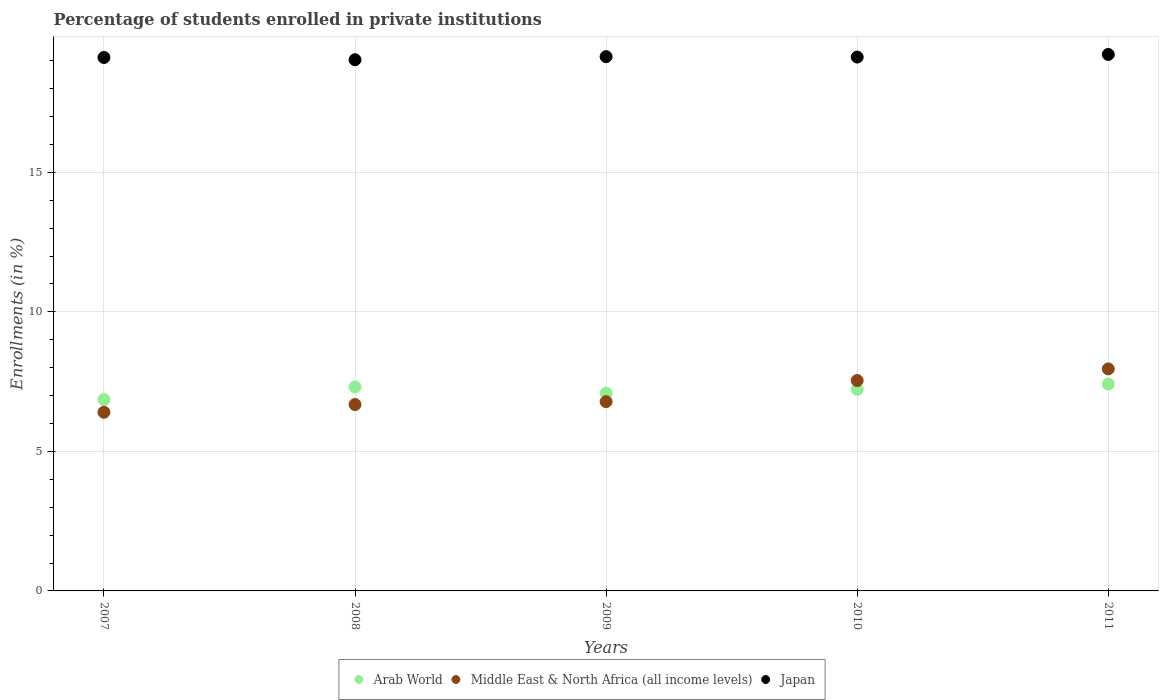How many different coloured dotlines are there?
Your response must be concise. 3. Is the number of dotlines equal to the number of legend labels?
Offer a terse response. Yes. What is the percentage of trained teachers in Arab World in 2011?
Provide a short and direct response. 7.41. Across all years, what is the maximum percentage of trained teachers in Middle East & North Africa (all income levels)?
Provide a succinct answer. 7.96. Across all years, what is the minimum percentage of trained teachers in Japan?
Ensure brevity in your answer.  19.04. What is the total percentage of trained teachers in Japan in the graph?
Give a very brief answer. 95.66. What is the difference between the percentage of trained teachers in Arab World in 2010 and that in 2011?
Your answer should be very brief. -0.19. What is the difference between the percentage of trained teachers in Arab World in 2011 and the percentage of trained teachers in Japan in 2007?
Give a very brief answer. -11.7. What is the average percentage of trained teachers in Japan per year?
Provide a succinct answer. 19.13. In the year 2008, what is the difference between the percentage of trained teachers in Japan and percentage of trained teachers in Middle East & North Africa (all income levels)?
Offer a terse response. 12.36. In how many years, is the percentage of trained teachers in Arab World greater than 18 %?
Your answer should be compact. 0. What is the ratio of the percentage of trained teachers in Japan in 2009 to that in 2010?
Offer a very short reply. 1. Is the percentage of trained teachers in Arab World in 2007 less than that in 2011?
Offer a terse response. Yes. Is the difference between the percentage of trained teachers in Japan in 2009 and 2011 greater than the difference between the percentage of trained teachers in Middle East & North Africa (all income levels) in 2009 and 2011?
Your answer should be compact. Yes. What is the difference between the highest and the second highest percentage of trained teachers in Japan?
Keep it short and to the point. 0.08. What is the difference between the highest and the lowest percentage of trained teachers in Japan?
Your answer should be compact. 0.19. Is the sum of the percentage of trained teachers in Arab World in 2010 and 2011 greater than the maximum percentage of trained teachers in Middle East & North Africa (all income levels) across all years?
Your answer should be very brief. Yes. Is the percentage of trained teachers in Japan strictly greater than the percentage of trained teachers in Middle East & North Africa (all income levels) over the years?
Offer a terse response. Yes. Is the percentage of trained teachers in Arab World strictly less than the percentage of trained teachers in Middle East & North Africa (all income levels) over the years?
Keep it short and to the point. No. How many dotlines are there?
Keep it short and to the point. 3. Are the values on the major ticks of Y-axis written in scientific E-notation?
Offer a terse response. No. Does the graph contain grids?
Offer a very short reply. Yes. How many legend labels are there?
Offer a very short reply. 3. How are the legend labels stacked?
Provide a succinct answer. Horizontal. What is the title of the graph?
Your answer should be compact. Percentage of students enrolled in private institutions. What is the label or title of the Y-axis?
Keep it short and to the point. Enrollments (in %). What is the Enrollments (in %) of Arab World in 2007?
Give a very brief answer. 6.86. What is the Enrollments (in %) of Middle East & North Africa (all income levels) in 2007?
Keep it short and to the point. 6.4. What is the Enrollments (in %) in Japan in 2007?
Your answer should be very brief. 19.12. What is the Enrollments (in %) in Arab World in 2008?
Make the answer very short. 7.31. What is the Enrollments (in %) in Middle East & North Africa (all income levels) in 2008?
Ensure brevity in your answer.  6.68. What is the Enrollments (in %) of Japan in 2008?
Make the answer very short. 19.04. What is the Enrollments (in %) of Arab World in 2009?
Make the answer very short. 7.09. What is the Enrollments (in %) in Middle East & North Africa (all income levels) in 2009?
Your response must be concise. 6.78. What is the Enrollments (in %) in Japan in 2009?
Offer a terse response. 19.15. What is the Enrollments (in %) in Arab World in 2010?
Your response must be concise. 7.23. What is the Enrollments (in %) in Middle East & North Africa (all income levels) in 2010?
Provide a succinct answer. 7.54. What is the Enrollments (in %) of Japan in 2010?
Your answer should be compact. 19.13. What is the Enrollments (in %) of Arab World in 2011?
Ensure brevity in your answer.  7.41. What is the Enrollments (in %) of Middle East & North Africa (all income levels) in 2011?
Offer a terse response. 7.96. What is the Enrollments (in %) in Japan in 2011?
Give a very brief answer. 19.22. Across all years, what is the maximum Enrollments (in %) in Arab World?
Make the answer very short. 7.41. Across all years, what is the maximum Enrollments (in %) of Middle East & North Africa (all income levels)?
Provide a short and direct response. 7.96. Across all years, what is the maximum Enrollments (in %) in Japan?
Provide a succinct answer. 19.22. Across all years, what is the minimum Enrollments (in %) of Arab World?
Ensure brevity in your answer.  6.86. Across all years, what is the minimum Enrollments (in %) in Middle East & North Africa (all income levels)?
Offer a terse response. 6.4. Across all years, what is the minimum Enrollments (in %) of Japan?
Ensure brevity in your answer.  19.04. What is the total Enrollments (in %) of Arab World in the graph?
Provide a succinct answer. 35.89. What is the total Enrollments (in %) of Middle East & North Africa (all income levels) in the graph?
Offer a very short reply. 35.36. What is the total Enrollments (in %) in Japan in the graph?
Your response must be concise. 95.66. What is the difference between the Enrollments (in %) in Arab World in 2007 and that in 2008?
Offer a very short reply. -0.45. What is the difference between the Enrollments (in %) of Middle East & North Africa (all income levels) in 2007 and that in 2008?
Make the answer very short. -0.28. What is the difference between the Enrollments (in %) of Japan in 2007 and that in 2008?
Provide a short and direct response. 0.08. What is the difference between the Enrollments (in %) of Arab World in 2007 and that in 2009?
Your answer should be very brief. -0.23. What is the difference between the Enrollments (in %) in Middle East & North Africa (all income levels) in 2007 and that in 2009?
Offer a very short reply. -0.38. What is the difference between the Enrollments (in %) in Japan in 2007 and that in 2009?
Your answer should be compact. -0.03. What is the difference between the Enrollments (in %) of Arab World in 2007 and that in 2010?
Your answer should be compact. -0.37. What is the difference between the Enrollments (in %) in Middle East & North Africa (all income levels) in 2007 and that in 2010?
Provide a succinct answer. -1.14. What is the difference between the Enrollments (in %) in Japan in 2007 and that in 2010?
Offer a very short reply. -0.02. What is the difference between the Enrollments (in %) in Arab World in 2007 and that in 2011?
Give a very brief answer. -0.55. What is the difference between the Enrollments (in %) in Middle East & North Africa (all income levels) in 2007 and that in 2011?
Your response must be concise. -1.55. What is the difference between the Enrollments (in %) of Japan in 2007 and that in 2011?
Your answer should be very brief. -0.11. What is the difference between the Enrollments (in %) in Arab World in 2008 and that in 2009?
Offer a terse response. 0.22. What is the difference between the Enrollments (in %) of Middle East & North Africa (all income levels) in 2008 and that in 2009?
Your response must be concise. -0.1. What is the difference between the Enrollments (in %) in Japan in 2008 and that in 2009?
Your response must be concise. -0.11. What is the difference between the Enrollments (in %) of Arab World in 2008 and that in 2010?
Give a very brief answer. 0.08. What is the difference between the Enrollments (in %) of Middle East & North Africa (all income levels) in 2008 and that in 2010?
Provide a short and direct response. -0.86. What is the difference between the Enrollments (in %) of Japan in 2008 and that in 2010?
Offer a terse response. -0.1. What is the difference between the Enrollments (in %) in Arab World in 2008 and that in 2011?
Offer a very short reply. -0.1. What is the difference between the Enrollments (in %) of Middle East & North Africa (all income levels) in 2008 and that in 2011?
Ensure brevity in your answer.  -1.28. What is the difference between the Enrollments (in %) in Japan in 2008 and that in 2011?
Provide a succinct answer. -0.19. What is the difference between the Enrollments (in %) of Arab World in 2009 and that in 2010?
Your response must be concise. -0.14. What is the difference between the Enrollments (in %) in Middle East & North Africa (all income levels) in 2009 and that in 2010?
Make the answer very short. -0.76. What is the difference between the Enrollments (in %) of Japan in 2009 and that in 2010?
Offer a very short reply. 0.01. What is the difference between the Enrollments (in %) in Arab World in 2009 and that in 2011?
Your answer should be compact. -0.33. What is the difference between the Enrollments (in %) of Middle East & North Africa (all income levels) in 2009 and that in 2011?
Ensure brevity in your answer.  -1.17. What is the difference between the Enrollments (in %) in Japan in 2009 and that in 2011?
Offer a terse response. -0.08. What is the difference between the Enrollments (in %) of Arab World in 2010 and that in 2011?
Provide a short and direct response. -0.19. What is the difference between the Enrollments (in %) of Middle East & North Africa (all income levels) in 2010 and that in 2011?
Offer a very short reply. -0.42. What is the difference between the Enrollments (in %) in Japan in 2010 and that in 2011?
Offer a terse response. -0.09. What is the difference between the Enrollments (in %) of Arab World in 2007 and the Enrollments (in %) of Middle East & North Africa (all income levels) in 2008?
Offer a very short reply. 0.18. What is the difference between the Enrollments (in %) of Arab World in 2007 and the Enrollments (in %) of Japan in 2008?
Provide a short and direct response. -12.18. What is the difference between the Enrollments (in %) of Middle East & North Africa (all income levels) in 2007 and the Enrollments (in %) of Japan in 2008?
Your response must be concise. -12.63. What is the difference between the Enrollments (in %) in Arab World in 2007 and the Enrollments (in %) in Middle East & North Africa (all income levels) in 2009?
Your answer should be very brief. 0.08. What is the difference between the Enrollments (in %) of Arab World in 2007 and the Enrollments (in %) of Japan in 2009?
Make the answer very short. -12.29. What is the difference between the Enrollments (in %) in Middle East & North Africa (all income levels) in 2007 and the Enrollments (in %) in Japan in 2009?
Provide a succinct answer. -12.74. What is the difference between the Enrollments (in %) in Arab World in 2007 and the Enrollments (in %) in Middle East & North Africa (all income levels) in 2010?
Give a very brief answer. -0.68. What is the difference between the Enrollments (in %) of Arab World in 2007 and the Enrollments (in %) of Japan in 2010?
Give a very brief answer. -12.27. What is the difference between the Enrollments (in %) of Middle East & North Africa (all income levels) in 2007 and the Enrollments (in %) of Japan in 2010?
Your response must be concise. -12.73. What is the difference between the Enrollments (in %) in Arab World in 2007 and the Enrollments (in %) in Middle East & North Africa (all income levels) in 2011?
Your answer should be compact. -1.1. What is the difference between the Enrollments (in %) of Arab World in 2007 and the Enrollments (in %) of Japan in 2011?
Offer a very short reply. -12.37. What is the difference between the Enrollments (in %) in Middle East & North Africa (all income levels) in 2007 and the Enrollments (in %) in Japan in 2011?
Your response must be concise. -12.82. What is the difference between the Enrollments (in %) of Arab World in 2008 and the Enrollments (in %) of Middle East & North Africa (all income levels) in 2009?
Keep it short and to the point. 0.53. What is the difference between the Enrollments (in %) in Arab World in 2008 and the Enrollments (in %) in Japan in 2009?
Keep it short and to the point. -11.84. What is the difference between the Enrollments (in %) of Middle East & North Africa (all income levels) in 2008 and the Enrollments (in %) of Japan in 2009?
Your response must be concise. -12.47. What is the difference between the Enrollments (in %) in Arab World in 2008 and the Enrollments (in %) in Middle East & North Africa (all income levels) in 2010?
Offer a terse response. -0.23. What is the difference between the Enrollments (in %) in Arab World in 2008 and the Enrollments (in %) in Japan in 2010?
Your answer should be very brief. -11.82. What is the difference between the Enrollments (in %) of Middle East & North Africa (all income levels) in 2008 and the Enrollments (in %) of Japan in 2010?
Make the answer very short. -12.45. What is the difference between the Enrollments (in %) in Arab World in 2008 and the Enrollments (in %) in Middle East & North Africa (all income levels) in 2011?
Make the answer very short. -0.65. What is the difference between the Enrollments (in %) of Arab World in 2008 and the Enrollments (in %) of Japan in 2011?
Your response must be concise. -11.92. What is the difference between the Enrollments (in %) in Middle East & North Africa (all income levels) in 2008 and the Enrollments (in %) in Japan in 2011?
Offer a very short reply. -12.54. What is the difference between the Enrollments (in %) in Arab World in 2009 and the Enrollments (in %) in Middle East & North Africa (all income levels) in 2010?
Offer a terse response. -0.45. What is the difference between the Enrollments (in %) in Arab World in 2009 and the Enrollments (in %) in Japan in 2010?
Make the answer very short. -12.05. What is the difference between the Enrollments (in %) in Middle East & North Africa (all income levels) in 2009 and the Enrollments (in %) in Japan in 2010?
Your answer should be very brief. -12.35. What is the difference between the Enrollments (in %) of Arab World in 2009 and the Enrollments (in %) of Middle East & North Africa (all income levels) in 2011?
Make the answer very short. -0.87. What is the difference between the Enrollments (in %) of Arab World in 2009 and the Enrollments (in %) of Japan in 2011?
Offer a terse response. -12.14. What is the difference between the Enrollments (in %) of Middle East & North Africa (all income levels) in 2009 and the Enrollments (in %) of Japan in 2011?
Provide a succinct answer. -12.44. What is the difference between the Enrollments (in %) in Arab World in 2010 and the Enrollments (in %) in Middle East & North Africa (all income levels) in 2011?
Your response must be concise. -0.73. What is the difference between the Enrollments (in %) of Arab World in 2010 and the Enrollments (in %) of Japan in 2011?
Your answer should be very brief. -12. What is the difference between the Enrollments (in %) in Middle East & North Africa (all income levels) in 2010 and the Enrollments (in %) in Japan in 2011?
Your response must be concise. -11.69. What is the average Enrollments (in %) in Arab World per year?
Offer a very short reply. 7.18. What is the average Enrollments (in %) of Middle East & North Africa (all income levels) per year?
Offer a very short reply. 7.07. What is the average Enrollments (in %) of Japan per year?
Keep it short and to the point. 19.13. In the year 2007, what is the difference between the Enrollments (in %) in Arab World and Enrollments (in %) in Middle East & North Africa (all income levels)?
Offer a terse response. 0.46. In the year 2007, what is the difference between the Enrollments (in %) in Arab World and Enrollments (in %) in Japan?
Provide a short and direct response. -12.26. In the year 2007, what is the difference between the Enrollments (in %) of Middle East & North Africa (all income levels) and Enrollments (in %) of Japan?
Keep it short and to the point. -12.71. In the year 2008, what is the difference between the Enrollments (in %) of Arab World and Enrollments (in %) of Middle East & North Africa (all income levels)?
Offer a very short reply. 0.63. In the year 2008, what is the difference between the Enrollments (in %) of Arab World and Enrollments (in %) of Japan?
Offer a terse response. -11.73. In the year 2008, what is the difference between the Enrollments (in %) in Middle East & North Africa (all income levels) and Enrollments (in %) in Japan?
Your answer should be compact. -12.36. In the year 2009, what is the difference between the Enrollments (in %) in Arab World and Enrollments (in %) in Middle East & North Africa (all income levels)?
Offer a terse response. 0.3. In the year 2009, what is the difference between the Enrollments (in %) in Arab World and Enrollments (in %) in Japan?
Give a very brief answer. -12.06. In the year 2009, what is the difference between the Enrollments (in %) in Middle East & North Africa (all income levels) and Enrollments (in %) in Japan?
Keep it short and to the point. -12.36. In the year 2010, what is the difference between the Enrollments (in %) in Arab World and Enrollments (in %) in Middle East & North Africa (all income levels)?
Keep it short and to the point. -0.31. In the year 2010, what is the difference between the Enrollments (in %) of Arab World and Enrollments (in %) of Japan?
Your answer should be very brief. -11.91. In the year 2010, what is the difference between the Enrollments (in %) in Middle East & North Africa (all income levels) and Enrollments (in %) in Japan?
Offer a terse response. -11.59. In the year 2011, what is the difference between the Enrollments (in %) of Arab World and Enrollments (in %) of Middle East & North Africa (all income levels)?
Your response must be concise. -0.54. In the year 2011, what is the difference between the Enrollments (in %) in Arab World and Enrollments (in %) in Japan?
Provide a succinct answer. -11.81. In the year 2011, what is the difference between the Enrollments (in %) of Middle East & North Africa (all income levels) and Enrollments (in %) of Japan?
Your response must be concise. -11.27. What is the ratio of the Enrollments (in %) of Arab World in 2007 to that in 2008?
Your response must be concise. 0.94. What is the ratio of the Enrollments (in %) of Middle East & North Africa (all income levels) in 2007 to that in 2008?
Provide a short and direct response. 0.96. What is the ratio of the Enrollments (in %) in Arab World in 2007 to that in 2009?
Ensure brevity in your answer.  0.97. What is the ratio of the Enrollments (in %) in Middle East & North Africa (all income levels) in 2007 to that in 2009?
Make the answer very short. 0.94. What is the ratio of the Enrollments (in %) of Japan in 2007 to that in 2009?
Ensure brevity in your answer.  1. What is the ratio of the Enrollments (in %) in Arab World in 2007 to that in 2010?
Provide a succinct answer. 0.95. What is the ratio of the Enrollments (in %) of Middle East & North Africa (all income levels) in 2007 to that in 2010?
Your response must be concise. 0.85. What is the ratio of the Enrollments (in %) in Arab World in 2007 to that in 2011?
Offer a terse response. 0.93. What is the ratio of the Enrollments (in %) of Middle East & North Africa (all income levels) in 2007 to that in 2011?
Provide a succinct answer. 0.8. What is the ratio of the Enrollments (in %) in Japan in 2007 to that in 2011?
Offer a very short reply. 0.99. What is the ratio of the Enrollments (in %) in Arab World in 2008 to that in 2009?
Ensure brevity in your answer.  1.03. What is the ratio of the Enrollments (in %) in Middle East & North Africa (all income levels) in 2008 to that in 2009?
Your answer should be compact. 0.98. What is the ratio of the Enrollments (in %) in Japan in 2008 to that in 2009?
Provide a short and direct response. 0.99. What is the ratio of the Enrollments (in %) in Arab World in 2008 to that in 2010?
Give a very brief answer. 1.01. What is the ratio of the Enrollments (in %) in Middle East & North Africa (all income levels) in 2008 to that in 2010?
Your answer should be compact. 0.89. What is the ratio of the Enrollments (in %) in Arab World in 2008 to that in 2011?
Keep it short and to the point. 0.99. What is the ratio of the Enrollments (in %) of Middle East & North Africa (all income levels) in 2008 to that in 2011?
Your response must be concise. 0.84. What is the ratio of the Enrollments (in %) of Japan in 2008 to that in 2011?
Provide a short and direct response. 0.99. What is the ratio of the Enrollments (in %) in Arab World in 2009 to that in 2010?
Provide a short and direct response. 0.98. What is the ratio of the Enrollments (in %) of Middle East & North Africa (all income levels) in 2009 to that in 2010?
Give a very brief answer. 0.9. What is the ratio of the Enrollments (in %) of Japan in 2009 to that in 2010?
Ensure brevity in your answer.  1. What is the ratio of the Enrollments (in %) in Arab World in 2009 to that in 2011?
Offer a terse response. 0.96. What is the ratio of the Enrollments (in %) in Middle East & North Africa (all income levels) in 2009 to that in 2011?
Offer a terse response. 0.85. What is the ratio of the Enrollments (in %) of Japan in 2009 to that in 2011?
Ensure brevity in your answer.  1. What is the ratio of the Enrollments (in %) of Arab World in 2010 to that in 2011?
Your response must be concise. 0.97. What is the ratio of the Enrollments (in %) in Middle East & North Africa (all income levels) in 2010 to that in 2011?
Provide a succinct answer. 0.95. What is the ratio of the Enrollments (in %) of Japan in 2010 to that in 2011?
Provide a succinct answer. 1. What is the difference between the highest and the second highest Enrollments (in %) of Arab World?
Your answer should be very brief. 0.1. What is the difference between the highest and the second highest Enrollments (in %) of Middle East & North Africa (all income levels)?
Offer a terse response. 0.42. What is the difference between the highest and the second highest Enrollments (in %) of Japan?
Provide a short and direct response. 0.08. What is the difference between the highest and the lowest Enrollments (in %) of Arab World?
Offer a very short reply. 0.55. What is the difference between the highest and the lowest Enrollments (in %) of Middle East & North Africa (all income levels)?
Your answer should be very brief. 1.55. What is the difference between the highest and the lowest Enrollments (in %) of Japan?
Offer a very short reply. 0.19. 